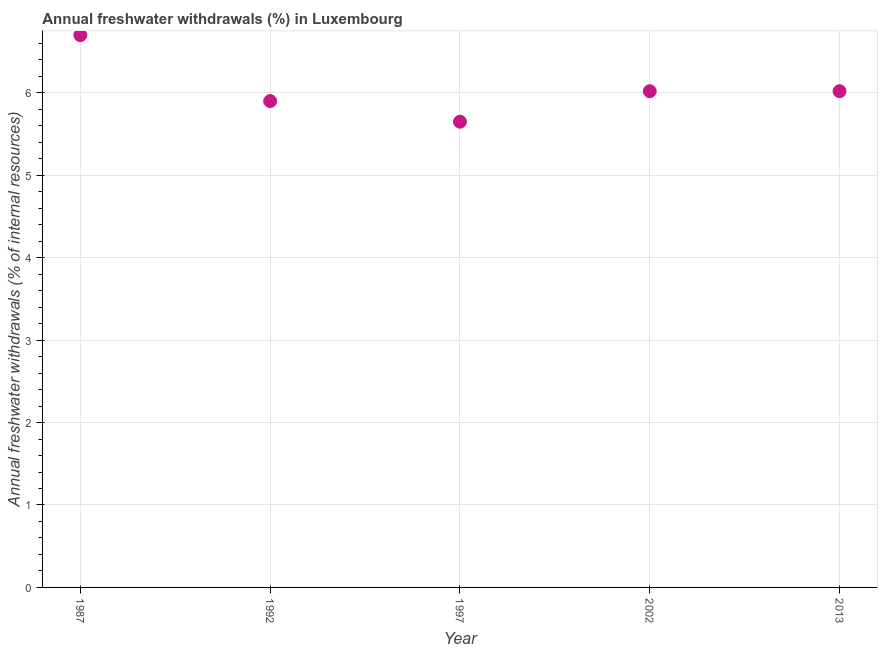What is the annual freshwater withdrawals in 2002?
Offer a very short reply. 6.02. Across all years, what is the minimum annual freshwater withdrawals?
Your answer should be compact. 5.65. What is the sum of the annual freshwater withdrawals?
Offer a terse response. 30.29. What is the difference between the annual freshwater withdrawals in 1987 and 1997?
Your answer should be very brief. 1.05. What is the average annual freshwater withdrawals per year?
Ensure brevity in your answer.  6.06. What is the median annual freshwater withdrawals?
Your answer should be compact. 6.02. Do a majority of the years between 1997 and 2013 (inclusive) have annual freshwater withdrawals greater than 2 %?
Your answer should be compact. Yes. What is the ratio of the annual freshwater withdrawals in 1987 to that in 1997?
Ensure brevity in your answer.  1.19. Is the difference between the annual freshwater withdrawals in 1987 and 1997 greater than the difference between any two years?
Provide a succinct answer. Yes. What is the difference between the highest and the second highest annual freshwater withdrawals?
Offer a terse response. 0.68. Is the sum of the annual freshwater withdrawals in 1992 and 1997 greater than the maximum annual freshwater withdrawals across all years?
Your response must be concise. Yes. What is the difference between the highest and the lowest annual freshwater withdrawals?
Offer a terse response. 1.05. In how many years, is the annual freshwater withdrawals greater than the average annual freshwater withdrawals taken over all years?
Keep it short and to the point. 1. How many dotlines are there?
Offer a very short reply. 1. What is the difference between two consecutive major ticks on the Y-axis?
Keep it short and to the point. 1. Does the graph contain grids?
Make the answer very short. Yes. What is the title of the graph?
Provide a succinct answer. Annual freshwater withdrawals (%) in Luxembourg. What is the label or title of the Y-axis?
Give a very brief answer. Annual freshwater withdrawals (% of internal resources). What is the Annual freshwater withdrawals (% of internal resources) in 1987?
Your answer should be compact. 6.7. What is the Annual freshwater withdrawals (% of internal resources) in 1997?
Make the answer very short. 5.65. What is the Annual freshwater withdrawals (% of internal resources) in 2002?
Give a very brief answer. 6.02. What is the Annual freshwater withdrawals (% of internal resources) in 2013?
Give a very brief answer. 6.02. What is the difference between the Annual freshwater withdrawals (% of internal resources) in 1987 and 2002?
Provide a succinct answer. 0.68. What is the difference between the Annual freshwater withdrawals (% of internal resources) in 1987 and 2013?
Offer a terse response. 0.68. What is the difference between the Annual freshwater withdrawals (% of internal resources) in 1992 and 2002?
Make the answer very short. -0.12. What is the difference between the Annual freshwater withdrawals (% of internal resources) in 1992 and 2013?
Give a very brief answer. -0.12. What is the difference between the Annual freshwater withdrawals (% of internal resources) in 1997 and 2002?
Provide a short and direct response. -0.37. What is the difference between the Annual freshwater withdrawals (% of internal resources) in 1997 and 2013?
Offer a terse response. -0.37. What is the ratio of the Annual freshwater withdrawals (% of internal resources) in 1987 to that in 1992?
Make the answer very short. 1.14. What is the ratio of the Annual freshwater withdrawals (% of internal resources) in 1987 to that in 1997?
Offer a very short reply. 1.19. What is the ratio of the Annual freshwater withdrawals (% of internal resources) in 1987 to that in 2002?
Provide a succinct answer. 1.11. What is the ratio of the Annual freshwater withdrawals (% of internal resources) in 1987 to that in 2013?
Make the answer very short. 1.11. What is the ratio of the Annual freshwater withdrawals (% of internal resources) in 1992 to that in 1997?
Ensure brevity in your answer.  1.04. What is the ratio of the Annual freshwater withdrawals (% of internal resources) in 1997 to that in 2002?
Your answer should be very brief. 0.94. What is the ratio of the Annual freshwater withdrawals (% of internal resources) in 1997 to that in 2013?
Offer a very short reply. 0.94. What is the ratio of the Annual freshwater withdrawals (% of internal resources) in 2002 to that in 2013?
Give a very brief answer. 1. 